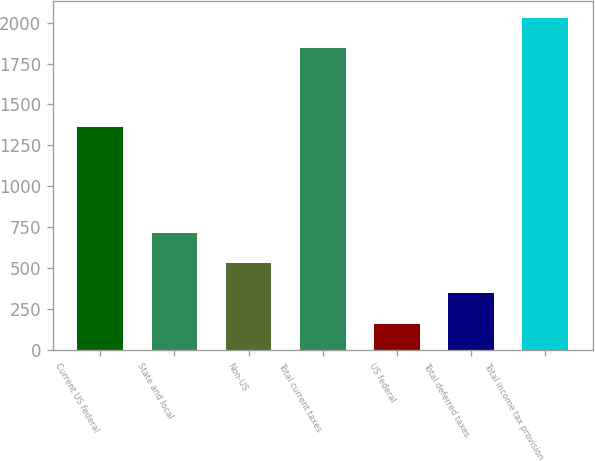Convert chart to OTSL. <chart><loc_0><loc_0><loc_500><loc_500><bar_chart><fcel>Current US federal<fcel>State and local<fcel>Non-US<fcel>Total current taxes<fcel>US federal<fcel>Total deferred taxes<fcel>Total income tax provision<nl><fcel>1365<fcel>715<fcel>530<fcel>1844<fcel>160<fcel>345<fcel>2029<nl></chart> 